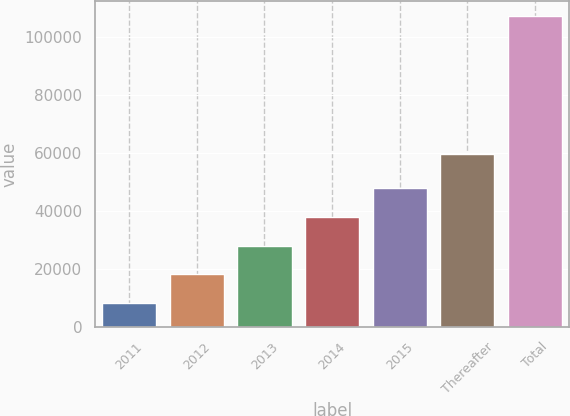<chart> <loc_0><loc_0><loc_500><loc_500><bar_chart><fcel>2011<fcel>2012<fcel>2013<fcel>2014<fcel>2015<fcel>Thereafter<fcel>Total<nl><fcel>8410<fcel>18274.8<fcel>28139.6<fcel>38004.4<fcel>47869.2<fcel>59818<fcel>107058<nl></chart> 